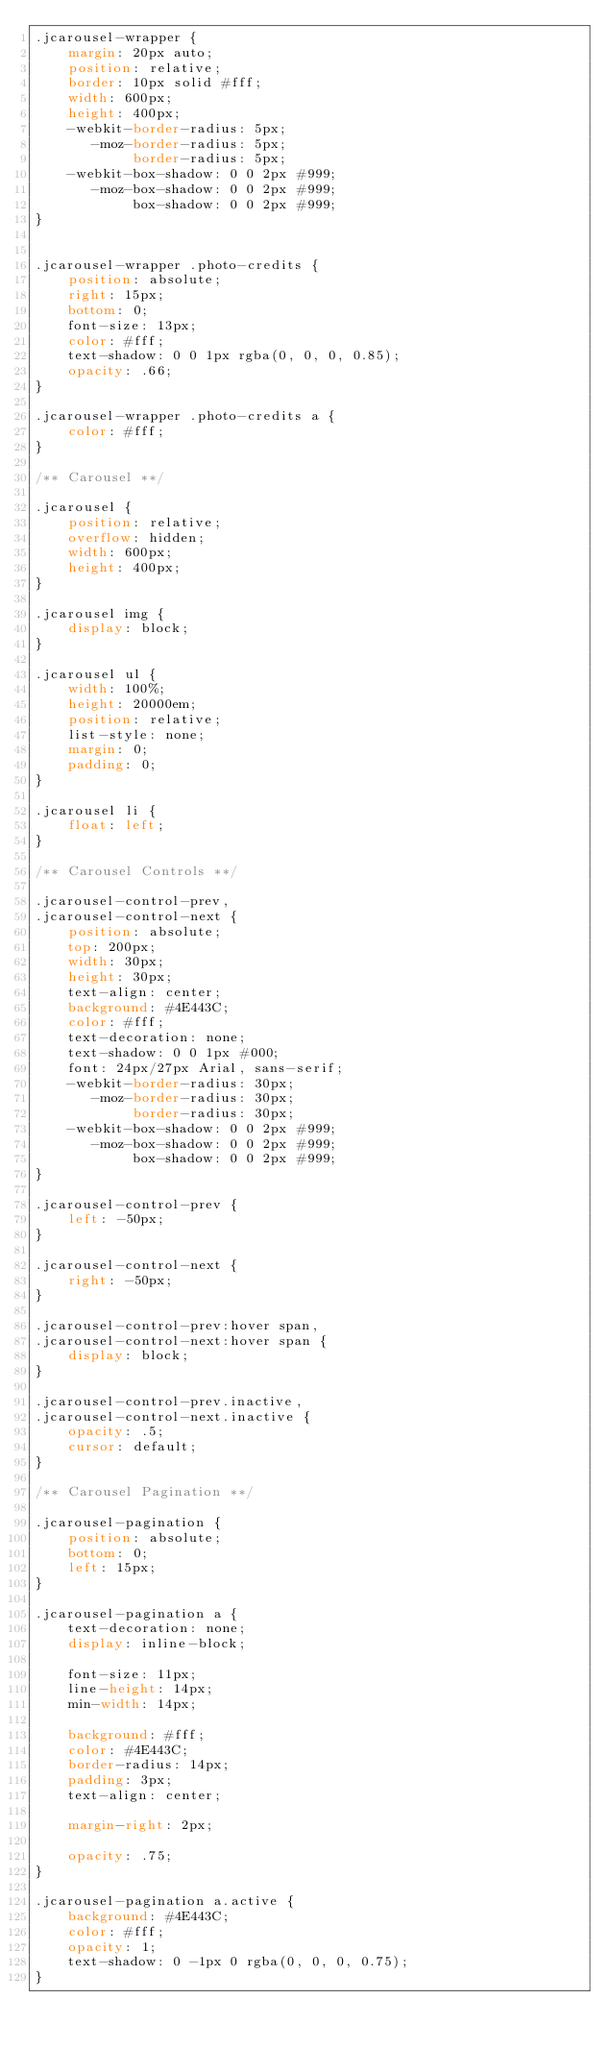Convert code to text. <code><loc_0><loc_0><loc_500><loc_500><_CSS_>.jcarousel-wrapper {
    margin: 20px auto;
    position: relative;
    border: 10px solid #fff;
    width: 600px;
    height: 400px;
    -webkit-border-radius: 5px;
       -moz-border-radius: 5px;
            border-radius: 5px;
    -webkit-box-shadow: 0 0 2px #999;
       -moz-box-shadow: 0 0 2px #999;
            box-shadow: 0 0 2px #999;
}


.jcarousel-wrapper .photo-credits {
    position: absolute;
    right: 15px;
    bottom: 0;
    font-size: 13px;
    color: #fff;
    text-shadow: 0 0 1px rgba(0, 0, 0, 0.85);
    opacity: .66;
}

.jcarousel-wrapper .photo-credits a {
    color: #fff;
}

/** Carousel **/

.jcarousel {
    position: relative;
    overflow: hidden;
    width: 600px;
    height: 400px;
}

.jcarousel img {
    display: block;
}

.jcarousel ul {
    width: 100%;
    height: 20000em;
    position: relative;
    list-style: none;
    margin: 0;
    padding: 0;
}

.jcarousel li {
    float: left;
}

/** Carousel Controls **/

.jcarousel-control-prev,
.jcarousel-control-next {
    position: absolute;
    top: 200px;
    width: 30px;
    height: 30px;
    text-align: center;
    background: #4E443C;
    color: #fff;
    text-decoration: none;
    text-shadow: 0 0 1px #000;
    font: 24px/27px Arial, sans-serif;
    -webkit-border-radius: 30px;
       -moz-border-radius: 30px;
            border-radius: 30px;
    -webkit-box-shadow: 0 0 2px #999;
       -moz-box-shadow: 0 0 2px #999;
            box-shadow: 0 0 2px #999;
}

.jcarousel-control-prev {
    left: -50px;
}

.jcarousel-control-next {
    right: -50px;
}

.jcarousel-control-prev:hover span,
.jcarousel-control-next:hover span {
    display: block;
}

.jcarousel-control-prev.inactive,
.jcarousel-control-next.inactive {
    opacity: .5;
    cursor: default;
}

/** Carousel Pagination **/

.jcarousel-pagination {
    position: absolute;
    bottom: 0;
    left: 15px;
}

.jcarousel-pagination a {
    text-decoration: none;
    display: inline-block;
    
    font-size: 11px;
    line-height: 14px;
    min-width: 14px;
    
    background: #fff;
    color: #4E443C;
    border-radius: 14px;
    padding: 3px;
    text-align: center;
    
    margin-right: 2px;
    
    opacity: .75;
}

.jcarousel-pagination a.active {
    background: #4E443C;
    color: #fff;
    opacity: 1;
    text-shadow: 0 -1px 0 rgba(0, 0, 0, 0.75);
}
</code> 